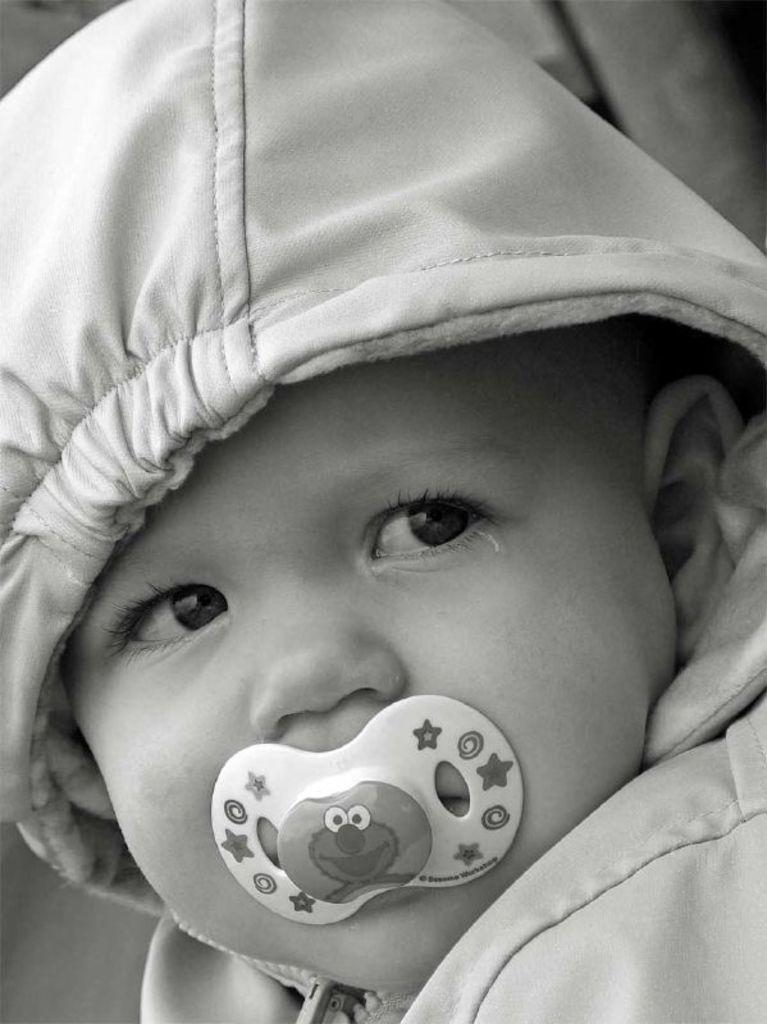What is the main object in the image? There is an object in the image, but its specific nature is not mentioned in the facts. Who or what else is present in the image? There is a child in the image. What type of material is visible in the image? There is cloth in the image. How would you describe the background of the image? The background of the image is blurry. What type of engine is powering the object in the image? There is no engine present in the image, as the specific nature of the object is not mentioned in the facts. Is there a bomb visible in the image? There is no mention of a bomb in the image, and the facts provided do not suggest its presence. 